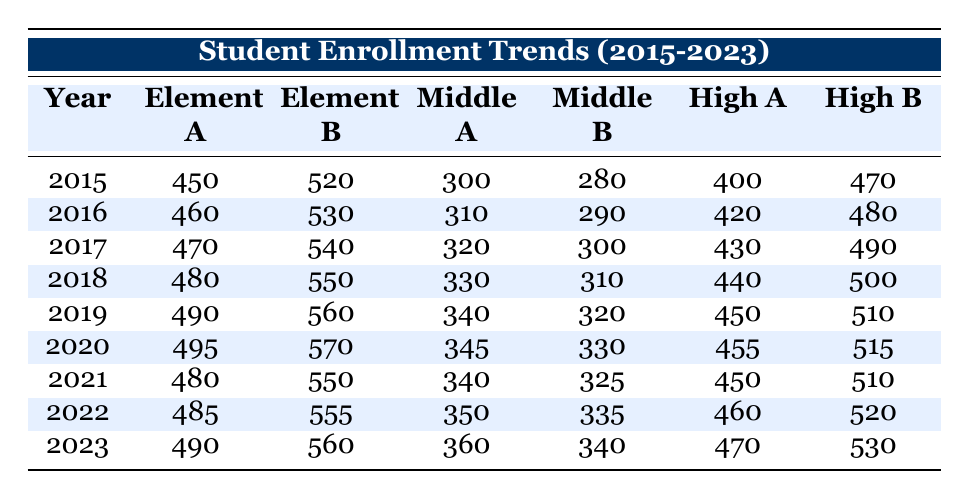What was the student enrollment in Middle School A in 2019? In the table, looking under the "Middle A" column for the year 2019, the value listed is 340.
Answer: 340 What was the total number of students enrolled in Elementary School A from 2015 to 2023? To find the total, we add the values: 450 + 460 + 470 + 480 + 490 + 495 + 480 + 485 + 490 = 3860.
Answer: 3860 Is the enrollment in High School B higher in 2023 compared to 2021? In 2023, the enrollment for High School B is 530, while in 2021 it is 510. Since 530 is greater than 510, the statement is true.
Answer: Yes What was the change in enrollment for Middle School B from 2015 to 2023? Middle School B had an enrollment of 280 in 2015 and 340 in 2023. The change is calculated as 340 - 280 = 60.
Answer: 60 What was the average enrollment in Elementary School B for the years 2020 to 2022? The enrollment figures for Elementary School B from 2020 to 2022 are 570, 550, and 555. To find the average, we sum these values: 570 + 550 + 555 = 1675, then divide by 3, which gives 1675 / 3 ≈ 558.33.
Answer: 558.33 Was there a decline in the enrollment of High School A from 2020 to 2021? In 2020, High School A had an enrollment of 455, and in 2021 it dropped to 450. Since 450 is less than 455, this indicates a decline.
Answer: Yes What is the total enrollment across all schools in 2018? The total for 2018 combines the values from each school: 480 (Elementary A) + 550 (Elementary B) + 330 (Middle A) + 310 (Middle B) + 440 (High A) + 500 (High B) = 2590.
Answer: 2590 How much more enrolled in Elementary School B compared to Elementary School A in 2017? In 2017, Elementary School B had an enrollment of 540 while Elementary School A had 470. The difference is 540 - 470 = 70.
Answer: 70 What was the trend in enrollment for Middle School A over the years? Reviewing the values for Middle School A from 2015 to 2023 shows a consistent increase: 300, 310, 320, 330, 340, 345, 340, 350, 360. It generally increased, except for a slight drop from 345 in 2020 to 340 in 2021 before rising again.
Answer: Generally increasing with a slight dip 